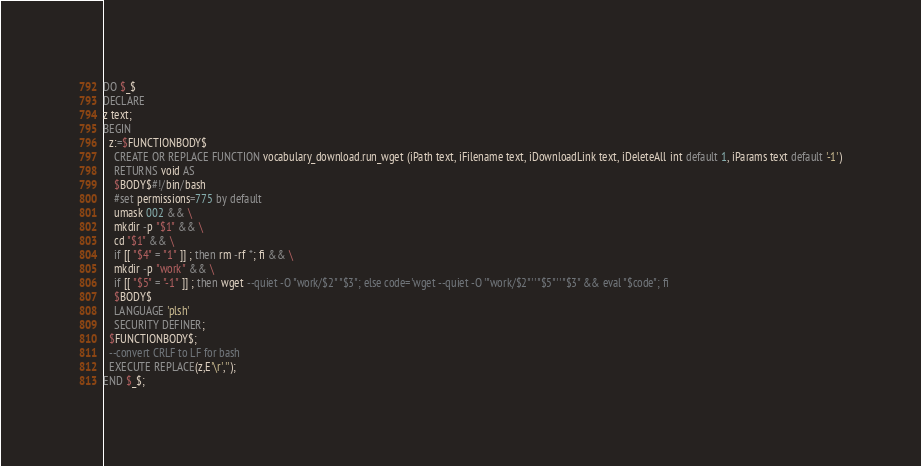Convert code to text. <code><loc_0><loc_0><loc_500><loc_500><_SQL_>DO $_$
DECLARE
z text;
BEGIN
  z:=$FUNCTIONBODY$
    CREATE OR REPLACE FUNCTION vocabulary_download.run_wget (iPath text, iFilename text, iDownloadLink text, iDeleteAll int default 1, iParams text default '-1')
    RETURNS void AS
    $BODY$#!/bin/bash
    #set permissions=775 by default
    umask 002 && \
    mkdir -p "$1" && \
    cd "$1" && \
    if [[ "$4" = "1" ]] ; then rm -rf *; fi && \
    mkdir -p "work" && \
    if [[ "$5" = "-1" ]] ; then wget --quiet -O "work/$2" "$3"; else code='wget --quiet -O '"work/$2"' '"$5"' '"$3" && eval "$code"; fi
    $BODY$
    LANGUAGE 'plsh'
    SECURITY DEFINER;
  $FUNCTIONBODY$;
  --convert CRLF to LF for bash
  EXECUTE REPLACE(z,E'\r','');
END $_$;</code> 